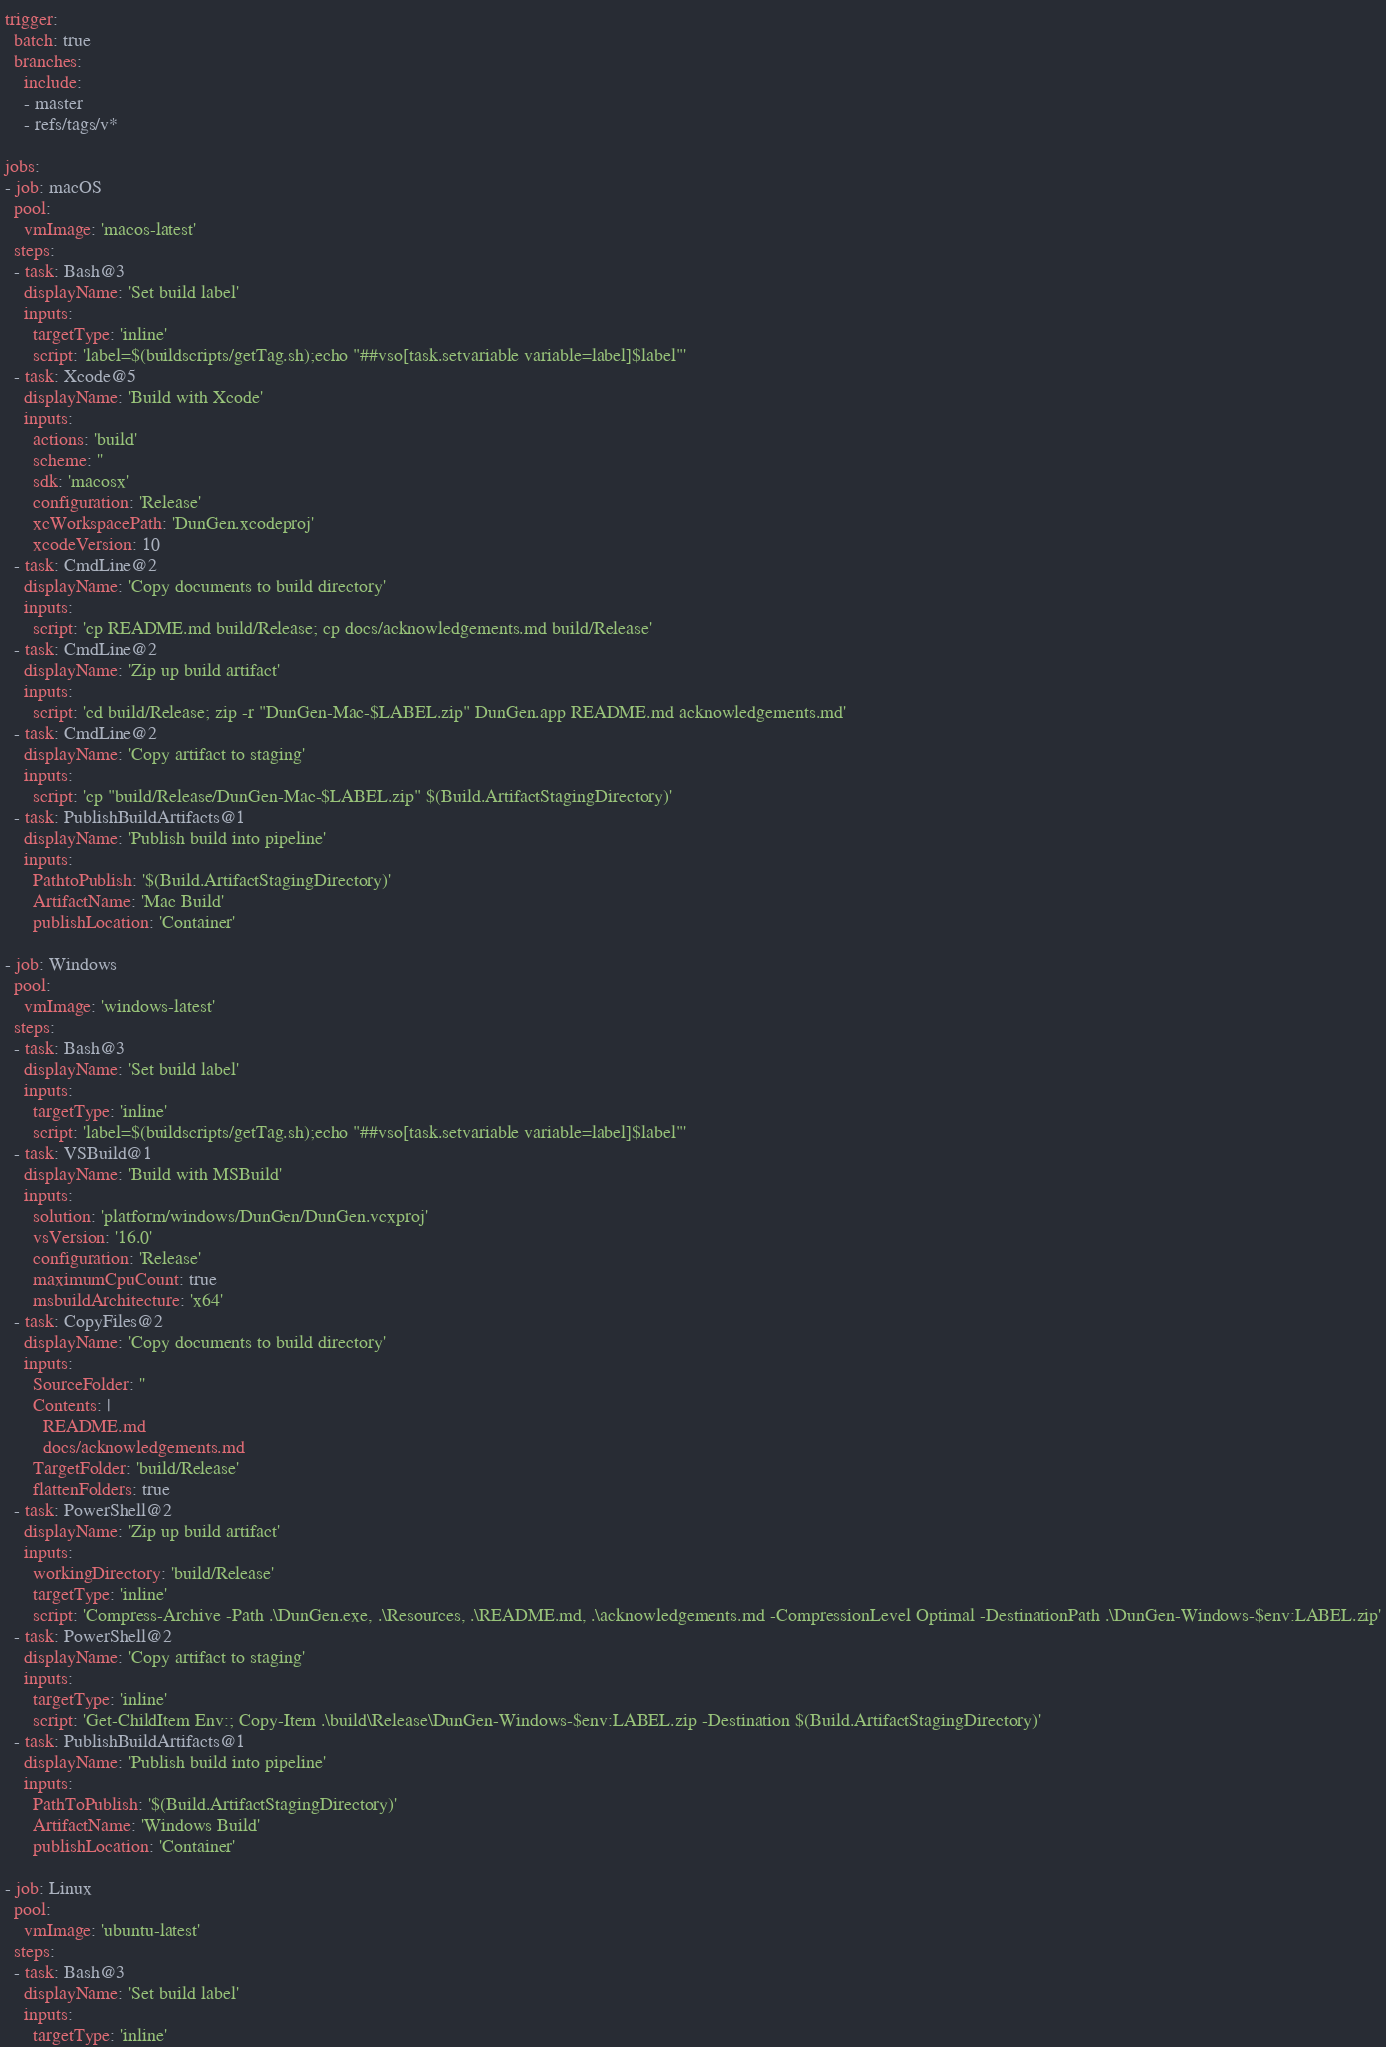<code> <loc_0><loc_0><loc_500><loc_500><_YAML_>trigger:
  batch: true
  branches:
    include:
    - master
    - refs/tags/v*

jobs:
- job: macOS
  pool:
    vmImage: 'macos-latest'
  steps:
  - task: Bash@3
    displayName: 'Set build label'
    inputs:
      targetType: 'inline'
      script: 'label=$(buildscripts/getTag.sh);echo "##vso[task.setvariable variable=label]$label"'
  - task: Xcode@5
    displayName: 'Build with Xcode'
    inputs:
      actions: 'build'
      scheme: ''
      sdk: 'macosx'
      configuration: 'Release'
      xcWorkspacePath: 'DunGen.xcodeproj'
      xcodeVersion: 10
  - task: CmdLine@2
    displayName: 'Copy documents to build directory'
    inputs:
      script: 'cp README.md build/Release; cp docs/acknowledgements.md build/Release'
  - task: CmdLine@2
    displayName: 'Zip up build artifact'
    inputs:
      script: 'cd build/Release; zip -r "DunGen-Mac-$LABEL.zip" DunGen.app README.md acknowledgements.md'
  - task: CmdLine@2
    displayName: 'Copy artifact to staging'
    inputs:
      script: 'cp "build/Release/DunGen-Mac-$LABEL.zip" $(Build.ArtifactStagingDirectory)'
  - task: PublishBuildArtifacts@1
    displayName: 'Publish build into pipeline'
    inputs:
      PathtoPublish: '$(Build.ArtifactStagingDirectory)'
      ArtifactName: 'Mac Build'
      publishLocation: 'Container'

- job: Windows
  pool:
    vmImage: 'windows-latest'
  steps:
  - task: Bash@3
    displayName: 'Set build label'
    inputs:
      targetType: 'inline'
      script: 'label=$(buildscripts/getTag.sh);echo "##vso[task.setvariable variable=label]$label"'
  - task: VSBuild@1
    displayName: 'Build with MSBuild'
    inputs:
      solution: 'platform/windows/DunGen/DunGen.vcxproj'
      vsVersion: '16.0'
      configuration: 'Release'
      maximumCpuCount: true
      msbuildArchitecture: 'x64'
  - task: CopyFiles@2
    displayName: 'Copy documents to build directory'
    inputs:
      SourceFolder: ''
      Contents: |
        README.md
        docs/acknowledgements.md
      TargetFolder: 'build/Release'
      flattenFolders: true
  - task: PowerShell@2
    displayName: 'Zip up build artifact'
    inputs:
      workingDirectory: 'build/Release'
      targetType: 'inline'
      script: 'Compress-Archive -Path .\DunGen.exe, .\Resources, .\README.md, .\acknowledgements.md -CompressionLevel Optimal -DestinationPath .\DunGen-Windows-$env:LABEL.zip'
  - task: PowerShell@2
    displayName: 'Copy artifact to staging'
    inputs:
      targetType: 'inline'
      script: 'Get-ChildItem Env:; Copy-Item .\build\Release\DunGen-Windows-$env:LABEL.zip -Destination $(Build.ArtifactStagingDirectory)'
  - task: PublishBuildArtifacts@1
    displayName: 'Publish build into pipeline'
    inputs:
      PathToPublish: '$(Build.ArtifactStagingDirectory)'
      ArtifactName: 'Windows Build'
      publishLocation: 'Container'

- job: Linux
  pool:
    vmImage: 'ubuntu-latest'
  steps:
  - task: Bash@3
    displayName: 'Set build label'
    inputs:
      targetType: 'inline'</code> 